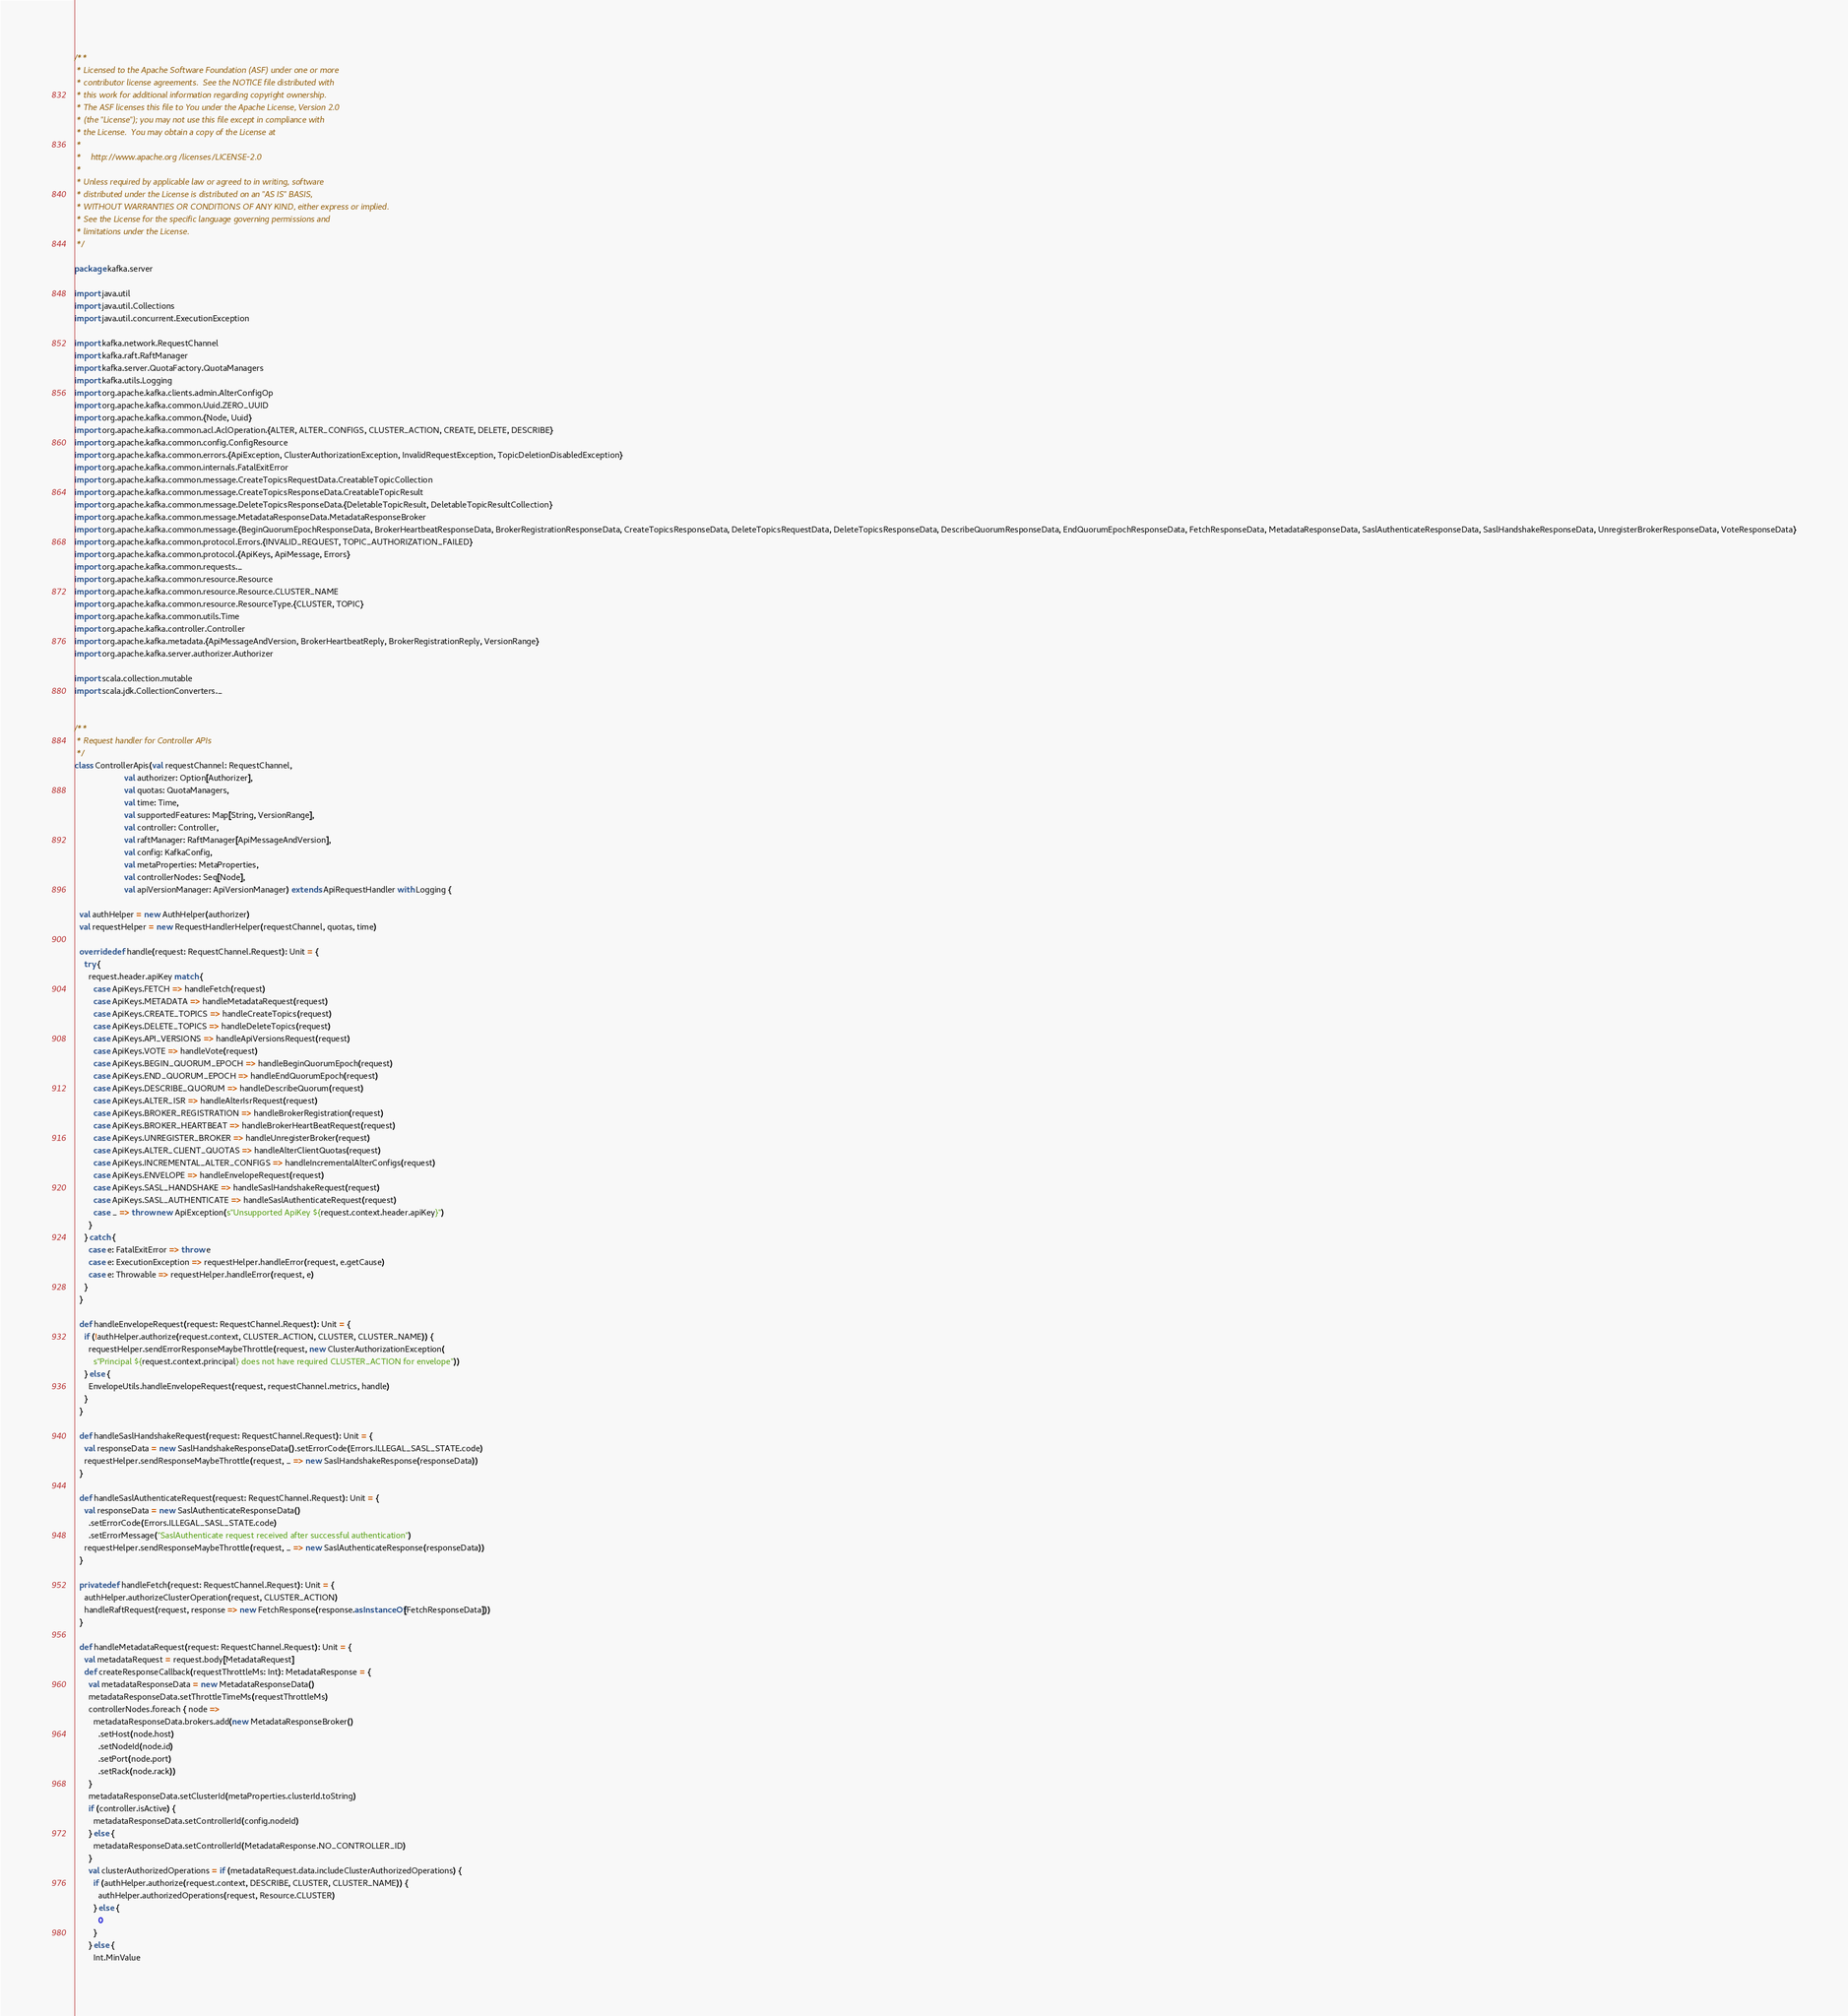Convert code to text. <code><loc_0><loc_0><loc_500><loc_500><_Scala_>/**
 * Licensed to the Apache Software Foundation (ASF) under one or more
 * contributor license agreements.  See the NOTICE file distributed with
 * this work for additional information regarding copyright ownership.
 * The ASF licenses this file to You under the Apache License, Version 2.0
 * (the "License"); you may not use this file except in compliance with
 * the License.  You may obtain a copy of the License at
 *
 *    http://www.apache.org/licenses/LICENSE-2.0
 *
 * Unless required by applicable law or agreed to in writing, software
 * distributed under the License is distributed on an "AS IS" BASIS,
 * WITHOUT WARRANTIES OR CONDITIONS OF ANY KIND, either express or implied.
 * See the License for the specific language governing permissions and
 * limitations under the License.
 */

package kafka.server

import java.util
import java.util.Collections
import java.util.concurrent.ExecutionException

import kafka.network.RequestChannel
import kafka.raft.RaftManager
import kafka.server.QuotaFactory.QuotaManagers
import kafka.utils.Logging
import org.apache.kafka.clients.admin.AlterConfigOp
import org.apache.kafka.common.Uuid.ZERO_UUID
import org.apache.kafka.common.{Node, Uuid}
import org.apache.kafka.common.acl.AclOperation.{ALTER, ALTER_CONFIGS, CLUSTER_ACTION, CREATE, DELETE, DESCRIBE}
import org.apache.kafka.common.config.ConfigResource
import org.apache.kafka.common.errors.{ApiException, ClusterAuthorizationException, InvalidRequestException, TopicDeletionDisabledException}
import org.apache.kafka.common.internals.FatalExitError
import org.apache.kafka.common.message.CreateTopicsRequestData.CreatableTopicCollection
import org.apache.kafka.common.message.CreateTopicsResponseData.CreatableTopicResult
import org.apache.kafka.common.message.DeleteTopicsResponseData.{DeletableTopicResult, DeletableTopicResultCollection}
import org.apache.kafka.common.message.MetadataResponseData.MetadataResponseBroker
import org.apache.kafka.common.message.{BeginQuorumEpochResponseData, BrokerHeartbeatResponseData, BrokerRegistrationResponseData, CreateTopicsResponseData, DeleteTopicsRequestData, DeleteTopicsResponseData, DescribeQuorumResponseData, EndQuorumEpochResponseData, FetchResponseData, MetadataResponseData, SaslAuthenticateResponseData, SaslHandshakeResponseData, UnregisterBrokerResponseData, VoteResponseData}
import org.apache.kafka.common.protocol.Errors.{INVALID_REQUEST, TOPIC_AUTHORIZATION_FAILED}
import org.apache.kafka.common.protocol.{ApiKeys, ApiMessage, Errors}
import org.apache.kafka.common.requests._
import org.apache.kafka.common.resource.Resource
import org.apache.kafka.common.resource.Resource.CLUSTER_NAME
import org.apache.kafka.common.resource.ResourceType.{CLUSTER, TOPIC}
import org.apache.kafka.common.utils.Time
import org.apache.kafka.controller.Controller
import org.apache.kafka.metadata.{ApiMessageAndVersion, BrokerHeartbeatReply, BrokerRegistrationReply, VersionRange}
import org.apache.kafka.server.authorizer.Authorizer

import scala.collection.mutable
import scala.jdk.CollectionConverters._


/**
 * Request handler for Controller APIs
 */
class ControllerApis(val requestChannel: RequestChannel,
                     val authorizer: Option[Authorizer],
                     val quotas: QuotaManagers,
                     val time: Time,
                     val supportedFeatures: Map[String, VersionRange],
                     val controller: Controller,
                     val raftManager: RaftManager[ApiMessageAndVersion],
                     val config: KafkaConfig,
                     val metaProperties: MetaProperties,
                     val controllerNodes: Seq[Node],
                     val apiVersionManager: ApiVersionManager) extends ApiRequestHandler with Logging {

  val authHelper = new AuthHelper(authorizer)
  val requestHelper = new RequestHandlerHelper(requestChannel, quotas, time)

  override def handle(request: RequestChannel.Request): Unit = {
    try {
      request.header.apiKey match {
        case ApiKeys.FETCH => handleFetch(request)
        case ApiKeys.METADATA => handleMetadataRequest(request)
        case ApiKeys.CREATE_TOPICS => handleCreateTopics(request)
        case ApiKeys.DELETE_TOPICS => handleDeleteTopics(request)
        case ApiKeys.API_VERSIONS => handleApiVersionsRequest(request)
        case ApiKeys.VOTE => handleVote(request)
        case ApiKeys.BEGIN_QUORUM_EPOCH => handleBeginQuorumEpoch(request)
        case ApiKeys.END_QUORUM_EPOCH => handleEndQuorumEpoch(request)
        case ApiKeys.DESCRIBE_QUORUM => handleDescribeQuorum(request)
        case ApiKeys.ALTER_ISR => handleAlterIsrRequest(request)
        case ApiKeys.BROKER_REGISTRATION => handleBrokerRegistration(request)
        case ApiKeys.BROKER_HEARTBEAT => handleBrokerHeartBeatRequest(request)
        case ApiKeys.UNREGISTER_BROKER => handleUnregisterBroker(request)
        case ApiKeys.ALTER_CLIENT_QUOTAS => handleAlterClientQuotas(request)
        case ApiKeys.INCREMENTAL_ALTER_CONFIGS => handleIncrementalAlterConfigs(request)
        case ApiKeys.ENVELOPE => handleEnvelopeRequest(request)
        case ApiKeys.SASL_HANDSHAKE => handleSaslHandshakeRequest(request)
        case ApiKeys.SASL_AUTHENTICATE => handleSaslAuthenticateRequest(request)
        case _ => throw new ApiException(s"Unsupported ApiKey ${request.context.header.apiKey}")
      }
    } catch {
      case e: FatalExitError => throw e
      case e: ExecutionException => requestHelper.handleError(request, e.getCause)
      case e: Throwable => requestHelper.handleError(request, e)
    }
  }

  def handleEnvelopeRequest(request: RequestChannel.Request): Unit = {
    if (!authHelper.authorize(request.context, CLUSTER_ACTION, CLUSTER, CLUSTER_NAME)) {
      requestHelper.sendErrorResponseMaybeThrottle(request, new ClusterAuthorizationException(
        s"Principal ${request.context.principal} does not have required CLUSTER_ACTION for envelope"))
    } else {
      EnvelopeUtils.handleEnvelopeRequest(request, requestChannel.metrics, handle)
    }
  }

  def handleSaslHandshakeRequest(request: RequestChannel.Request): Unit = {
    val responseData = new SaslHandshakeResponseData().setErrorCode(Errors.ILLEGAL_SASL_STATE.code)
    requestHelper.sendResponseMaybeThrottle(request, _ => new SaslHandshakeResponse(responseData))
  }

  def handleSaslAuthenticateRequest(request: RequestChannel.Request): Unit = {
    val responseData = new SaslAuthenticateResponseData()
      .setErrorCode(Errors.ILLEGAL_SASL_STATE.code)
      .setErrorMessage("SaslAuthenticate request received after successful authentication")
    requestHelper.sendResponseMaybeThrottle(request, _ => new SaslAuthenticateResponse(responseData))
  }

  private def handleFetch(request: RequestChannel.Request): Unit = {
    authHelper.authorizeClusterOperation(request, CLUSTER_ACTION)
    handleRaftRequest(request, response => new FetchResponse(response.asInstanceOf[FetchResponseData]))
  }

  def handleMetadataRequest(request: RequestChannel.Request): Unit = {
    val metadataRequest = request.body[MetadataRequest]
    def createResponseCallback(requestThrottleMs: Int): MetadataResponse = {
      val metadataResponseData = new MetadataResponseData()
      metadataResponseData.setThrottleTimeMs(requestThrottleMs)
      controllerNodes.foreach { node =>
        metadataResponseData.brokers.add(new MetadataResponseBroker()
          .setHost(node.host)
          .setNodeId(node.id)
          .setPort(node.port)
          .setRack(node.rack))
      }
      metadataResponseData.setClusterId(metaProperties.clusterId.toString)
      if (controller.isActive) {
        metadataResponseData.setControllerId(config.nodeId)
      } else {
        metadataResponseData.setControllerId(MetadataResponse.NO_CONTROLLER_ID)
      }
      val clusterAuthorizedOperations = if (metadataRequest.data.includeClusterAuthorizedOperations) {
        if (authHelper.authorize(request.context, DESCRIBE, CLUSTER, CLUSTER_NAME)) {
          authHelper.authorizedOperations(request, Resource.CLUSTER)
        } else {
          0
        }
      } else {
        Int.MinValue</code> 